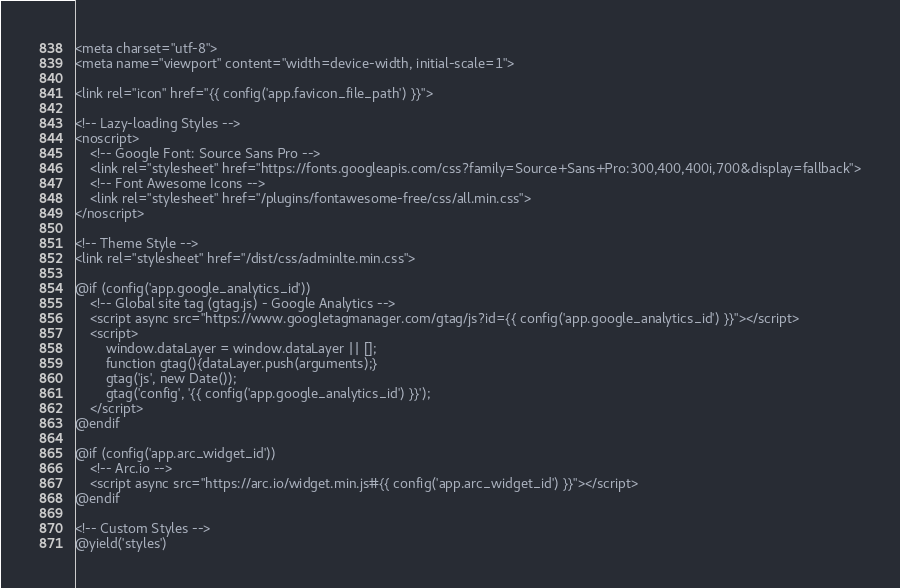<code> <loc_0><loc_0><loc_500><loc_500><_PHP_><meta charset="utf-8">
<meta name="viewport" content="width=device-width, initial-scale=1">

<link rel="icon" href="{{ config('app.favicon_file_path') }}">

<!-- Lazy-loading Styles -->
<noscript>
    <!-- Google Font: Source Sans Pro -->
    <link rel="stylesheet" href="https://fonts.googleapis.com/css?family=Source+Sans+Pro:300,400,400i,700&display=fallback">
    <!-- Font Awesome Icons -->
    <link rel="stylesheet" href="/plugins/fontawesome-free/css/all.min.css">
</noscript>

<!-- Theme Style -->
<link rel="stylesheet" href="/dist/css/adminlte.min.css">

@if (config('app.google_analytics_id'))
    <!-- Global site tag (gtag.js) - Google Analytics -->
    <script async src="https://www.googletagmanager.com/gtag/js?id={{ config('app.google_analytics_id') }}"></script>
    <script>
        window.dataLayer = window.dataLayer || [];
        function gtag(){dataLayer.push(arguments);}
        gtag('js', new Date());
        gtag('config', '{{ config('app.google_analytics_id') }}');
    </script>
@endif
    
@if (config('app.arc_widget_id'))
    <!-- Arc.io -->
    <script async src="https://arc.io/widget.min.js#{{ config('app.arc_widget_id') }}"></script>
@endif

<!-- Custom Styles -->
@yield('styles')
</code> 